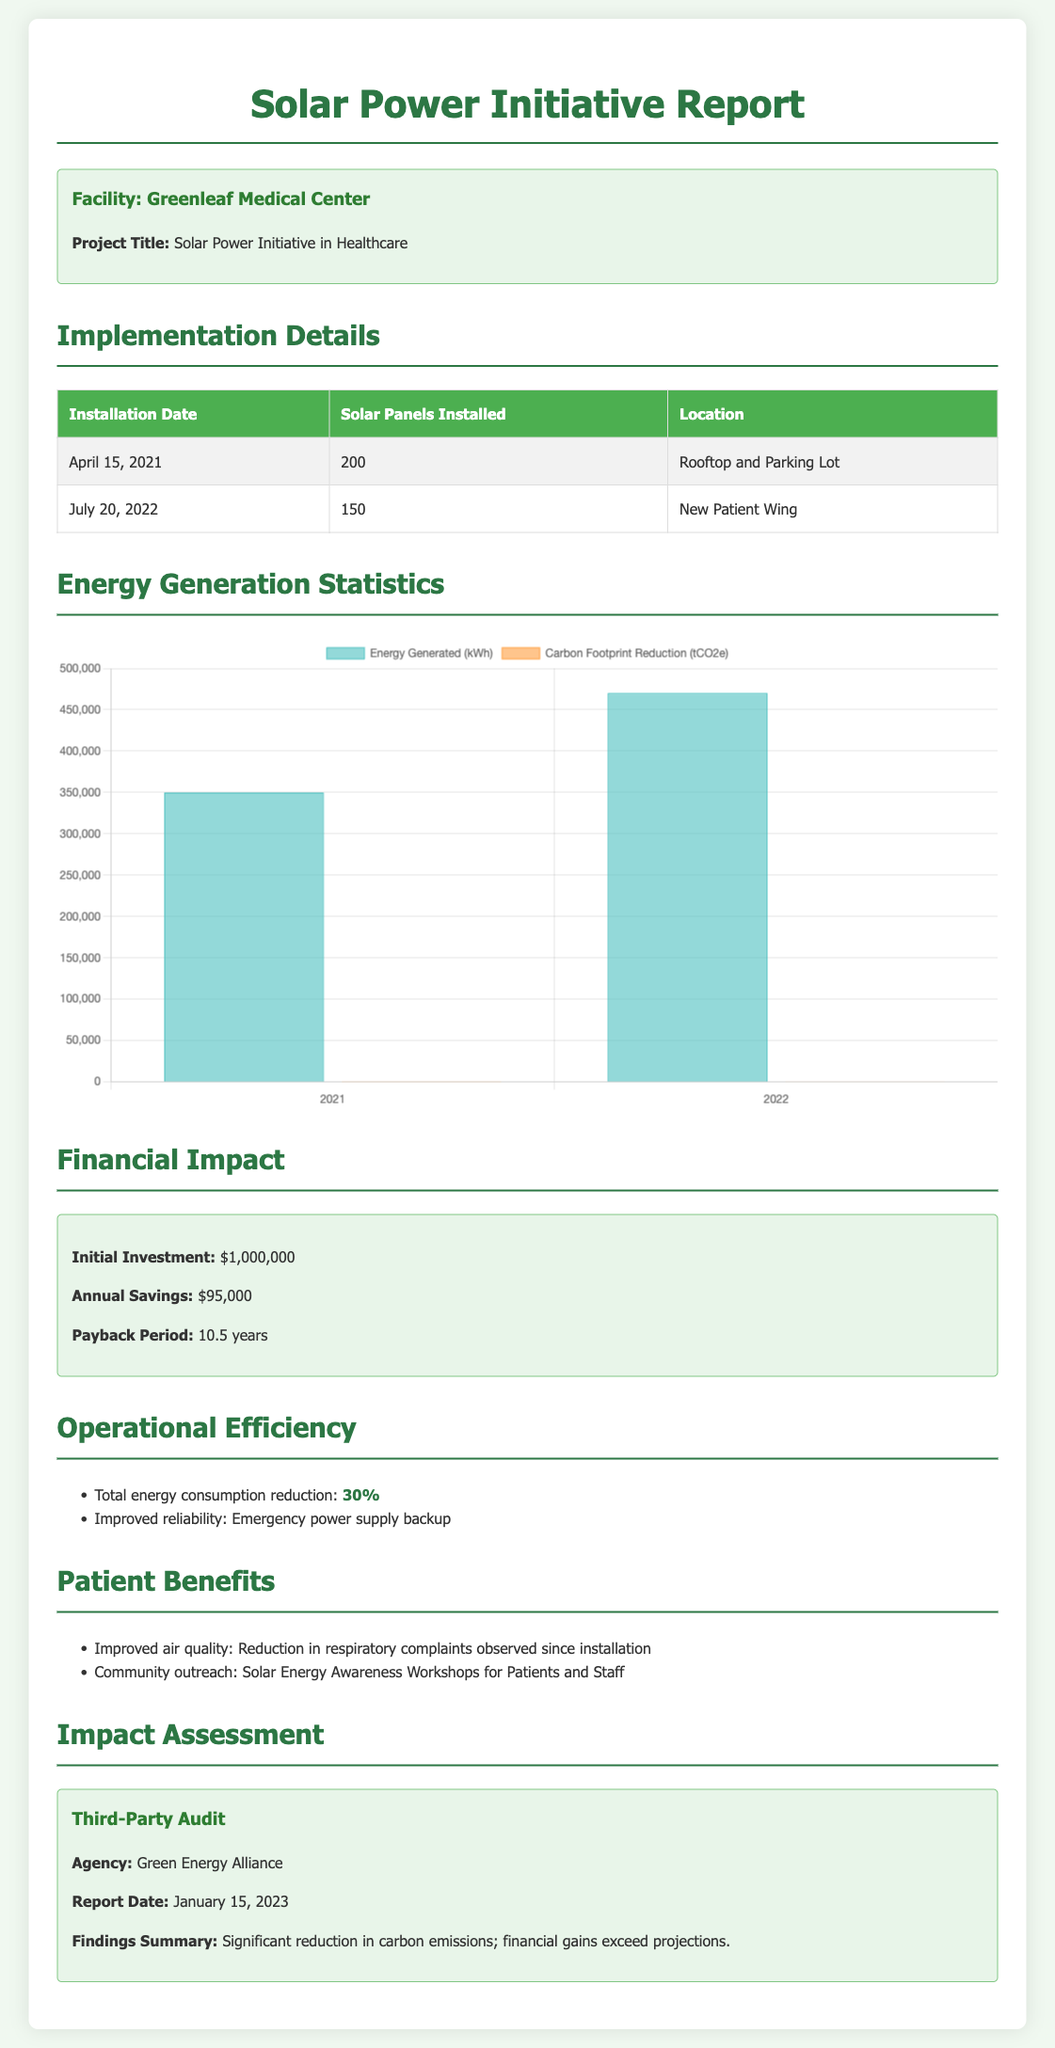What is the installation date of the first solar panel? The first solar panel was installed on April 15, 2021.
Answer: April 15, 2021 How many solar panels were installed at the New Patient Wing? The New Patient Wing had 150 solar panels installed.
Answer: 150 What is the annual savings from the solar power system? The annual savings from the solar power system is mentioned as $95,000.
Answer: $95,000 What was the initial investment for the solar power initiative? The document states the initial investment was $1,000,000.
Answer: $1,000,000 What agency conducted the third-party audit? The third-party audit was conducted by the Green Energy Alliance.
Answer: Green Energy Alliance What was the total energy consumption reduction percentage? The total energy consumption reduction percentage is stated as 30%.
Answer: 30% What were the energy generated in 2022? The energy generated in 2022 was 470,000 kWh.
Answer: 470,000 kWh What is the payback period for the solar initiative? The payback period for the solar initiative is stated as 10.5 years.
Answer: 10.5 years What is one benefit of the solar installation for patients? One benefit mentioned is improved air quality.
Answer: Improved air quality 